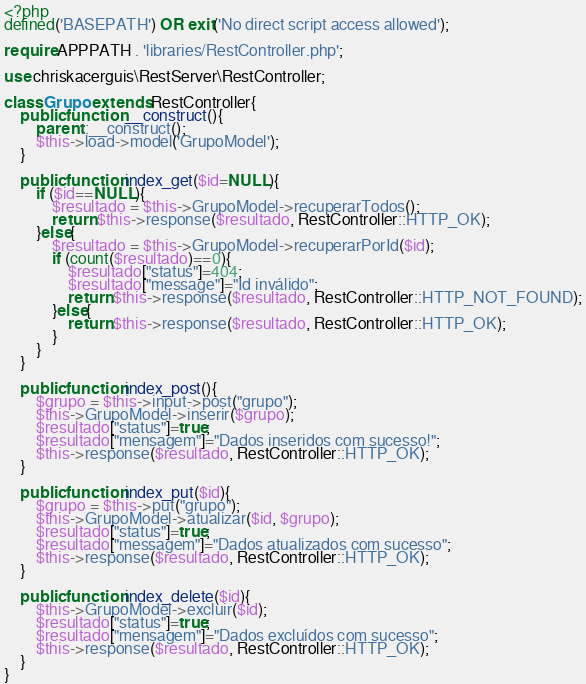Convert code to text. <code><loc_0><loc_0><loc_500><loc_500><_PHP_><?php
defined('BASEPATH') OR exit('No direct script access allowed');

require APPPATH . 'libraries/RestController.php';

use chriskacerguis\RestServer\RestController;

class Grupo extends RestController{
    public function __construct(){
        parent::__construct();
        $this->load->model('GrupoModel');
    }

    public function index_get($id=NULL){
        if ($id==NULL){
            $resultado = $this->GrupoModel->recuperarTodos();
            return $this->response($resultado, RestController::HTTP_OK);
        }else{
            $resultado = $this->GrupoModel->recuperarPorId($id);
            if (count($resultado)==0){
                $resultado["status"]=404;
                $resultado["message"]="Id inválido";
                return $this->response($resultado, RestController::HTTP_NOT_FOUND);
            }else{
                return $this->response($resultado, RestController::HTTP_OK);
            }
        }
    }

    public function index_post(){
        $grupo = $this->input->post("grupo");
        $this->GrupoModel->inserir($grupo);
        $resultado["status"]=true;
        $resultado["mensagem"]="Dados inseridos com sucesso!";
        $this->response($resultado, RestController::HTTP_OK);
    }

    public function index_put($id){
        $grupo = $this->put("grupo");
        $this->GrupoModel->atualizar($id, $grupo);
        $resultado["status"]=true;
        $resultado["messagem"]="Dados atualizados com sucesso";
        $this->response($resultado, RestController::HTTP_OK);
    }

    public function index_delete($id){
        $this->GrupoModel->excluir($id);
        $resultado["status"]=true;
        $resultado["mensagem"]="Dados excluídos com sucesso";
        $this->response($resultado, RestController::HTTP_OK);
    }
}
</code> 